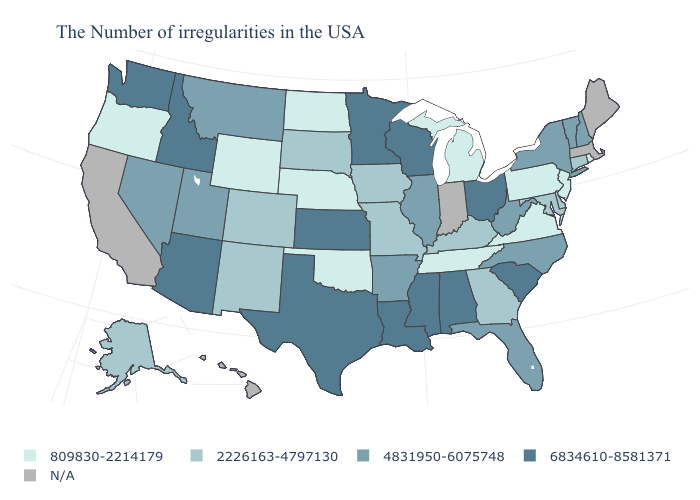How many symbols are there in the legend?
Quick response, please. 5. Name the states that have a value in the range 809830-2214179?
Give a very brief answer. Rhode Island, New Jersey, Pennsylvania, Virginia, Michigan, Tennessee, Nebraska, Oklahoma, North Dakota, Wyoming, Oregon. Does the first symbol in the legend represent the smallest category?
Answer briefly. Yes. Name the states that have a value in the range 809830-2214179?
Be succinct. Rhode Island, New Jersey, Pennsylvania, Virginia, Michigan, Tennessee, Nebraska, Oklahoma, North Dakota, Wyoming, Oregon. What is the highest value in the USA?
Concise answer only. 6834610-8581371. What is the value of Wyoming?
Answer briefly. 809830-2214179. Name the states that have a value in the range 2226163-4797130?
Keep it brief. Connecticut, Delaware, Maryland, Georgia, Kentucky, Missouri, Iowa, South Dakota, Colorado, New Mexico, Alaska. Which states hav the highest value in the South?
Short answer required. South Carolina, Alabama, Mississippi, Louisiana, Texas. Is the legend a continuous bar?
Quick response, please. No. Is the legend a continuous bar?
Short answer required. No. Which states have the lowest value in the MidWest?
Write a very short answer. Michigan, Nebraska, North Dakota. Name the states that have a value in the range 6834610-8581371?
Be succinct. South Carolina, Ohio, Alabama, Wisconsin, Mississippi, Louisiana, Minnesota, Kansas, Texas, Arizona, Idaho, Washington. What is the value of Wyoming?
Answer briefly. 809830-2214179. 